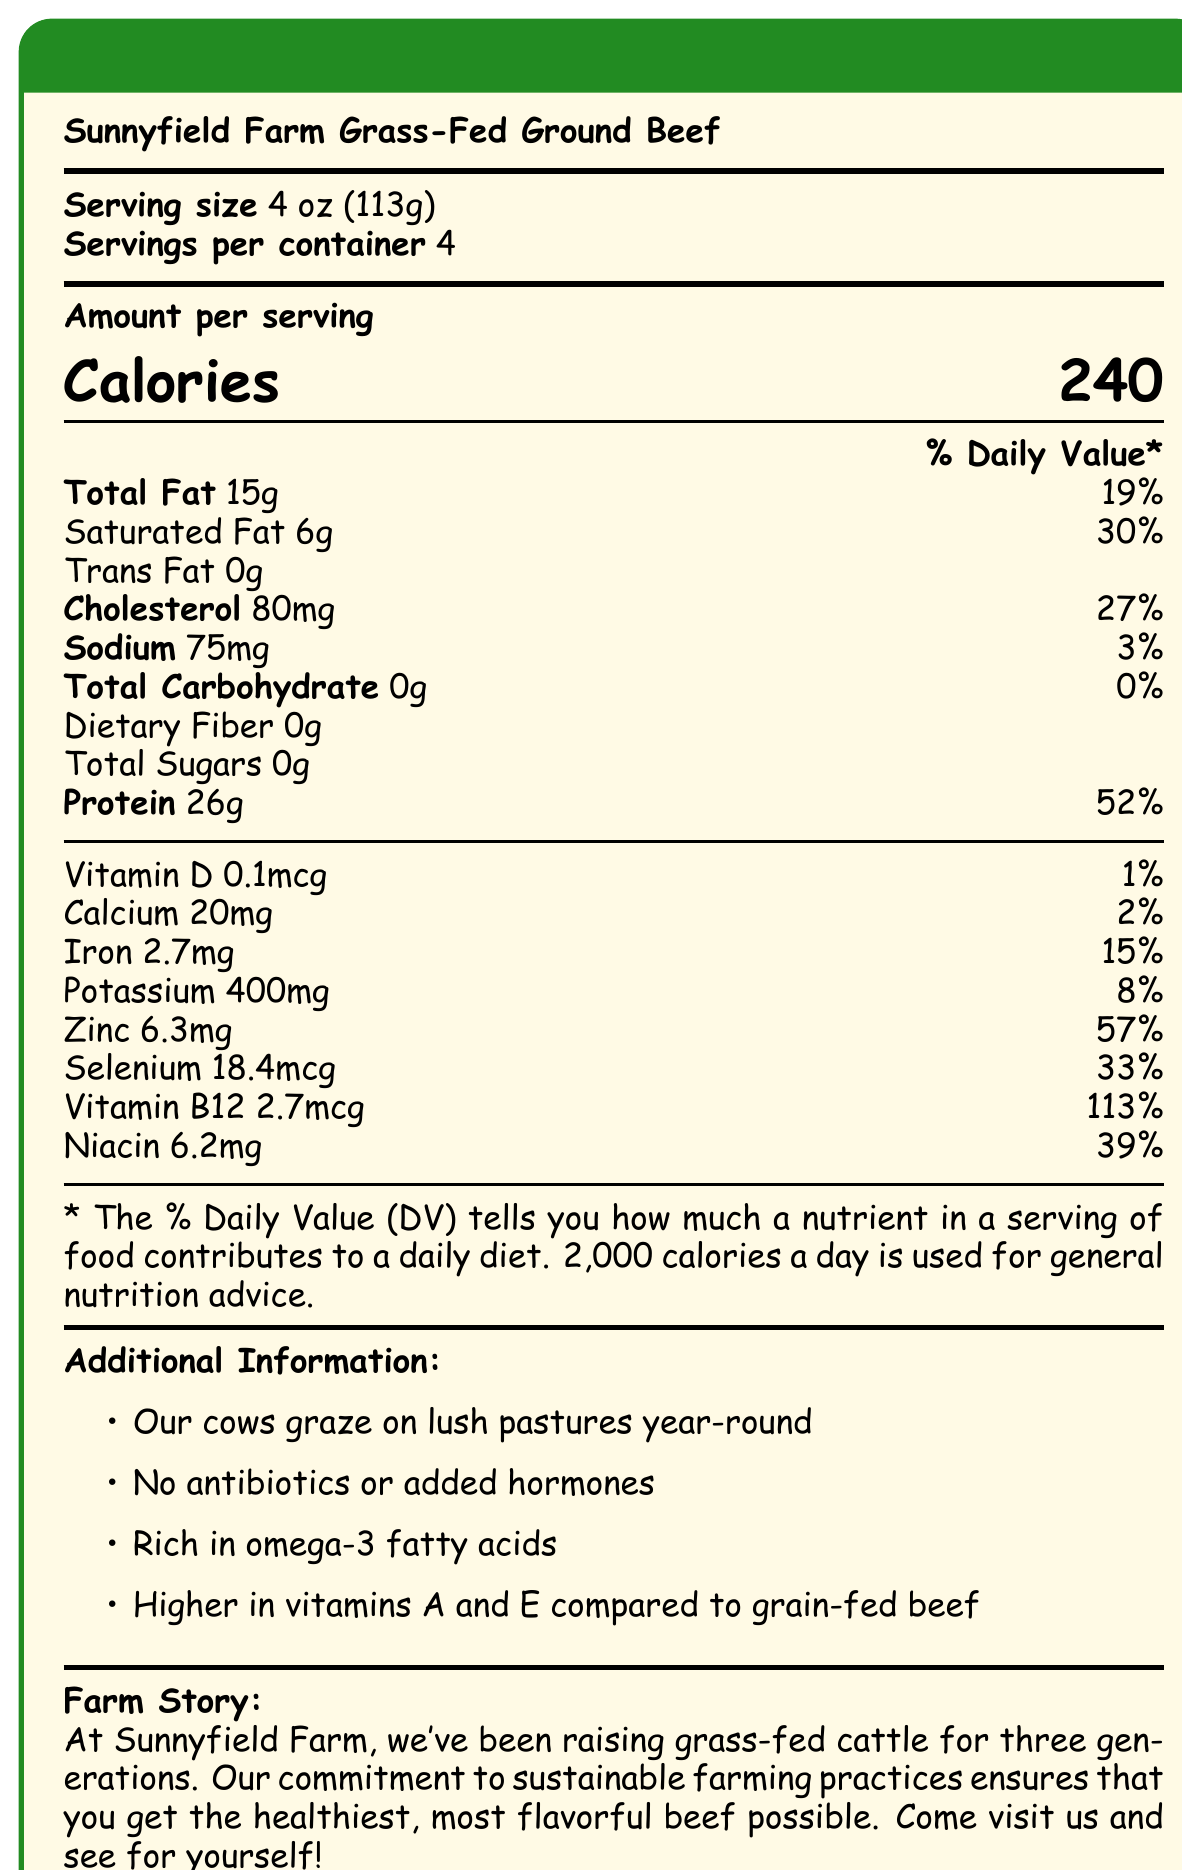what is the serving size of the Sunnyfield Farm Grass-Fed Ground Beef? The document clearly specifies the serving size as "4 oz (113g)" in the initial section.
Answer: 4 oz (113g) what is the amount of protein per serving? The amount of protein per serving is listed as "26g", noted next to "Protein" in the \% Daily Value section.
Answer: 26g how much iron is present per serving of the beef? The document indicates that each serving contains "2.7mg" of iron.
Answer: 2.7mg does the beef contain any trans fat? The document explicitly states "Trans Fat 0g", indicating that there is no trans fat in the beef.
Answer: No what is the daily value percentage of vitamin B12 per serving? The document shows that the vitamin B12 content per serving meets "113\%" of the daily value.
Answer: 113% how many calories are in one serving of the Sunnyfield Farm Grass-Fed Ground Beef? A. 120 B. 180 C. 220 D. 240 The document specifies that one serving contains "240" calories.
Answer: D. 240 which mineral has the highest daily value percentage? A. Calcium B. Iron C. Zinc D. Potassium Zinc has the highest daily value percentage at "57%", higher than calcium, iron, and potassium as listed.
Answer: C. Zinc is there any added sugar in the beef? The document lists "Total Sugars 0g", indicating there is no added sugar.
Answer: No how much selenium is in each serving, and what is its daily value percentage? The document states there is "18.4mcg" of selenium per serving, making up "33%" of the daily value.
Answer: 18.4mcg, 33% is this beef higher in vitamins compared to grain-fed beef? The additional information section mentions that the beef is "Higher in vitamins A and E compared to grain-fed beef".
Answer: Yes summarize the main points provided in the document The explanation covers the essential nutritional information and highlights the supplementary details about the farming practices and benefits of the beef.
Answer: The document is a nutrition facts label for Sunnyfield Farm Grass-Fed Ground Beef, detailing the nutritional content per 4 oz (113g) serving. Each serving contains 240 calories, 15g of total fat, 26g of protein, and no carbohydrates. It provides significant amounts of minerals like zinc, selenium, potassium, and iron, as well as vitamins B12 and niacin. Additional information emphasizes the cattle's grass-fed diet, absence of antibiotics or hormones, and the farm's commitment to sustainable practices. There are also claims about higher omega-3 fatty acids and vitamins A and E levels compared to grain-fed beef. how many grams of dietary fiber does the beef contain? The document mentions "Dietary Fiber 0g", indicating that the beef contains no dietary fiber.
Answer: 0g how much sodium is in each serving, and what is its daily value percentage? The document lists the sodium content as "75mg", with a daily value percentage of "3%".
Answer: 75mg, 3% does the document state if the cows are given antibiotics or added hormones? The additional information section states "No antibiotics or added hormones", confirming that the cows are not given any.
Answer: No which vitamin has the highest daily value percentage per serving? A. Vitamin D B. Calcium C. Vitamin B12 D. Niacin The document shows vitamin B12 at "113%" of the daily value, which is the highest percentage among the listed vitamins.
Answer: C. Vitamin B12 how many servings are there per container? The document specifies that there are "4" servings per container.
Answer: 4 does the document mention the beef's cholesterol content? The document includes the cholesterol content, listed as "80mg" per serving with a "27%" daily value.
Answer: Yes where is Sunnyfield Farm located? The document does not provide any specific location information about Sunnyfield Farm, merely describing its farming practices.
Answer: Cannot be determined 